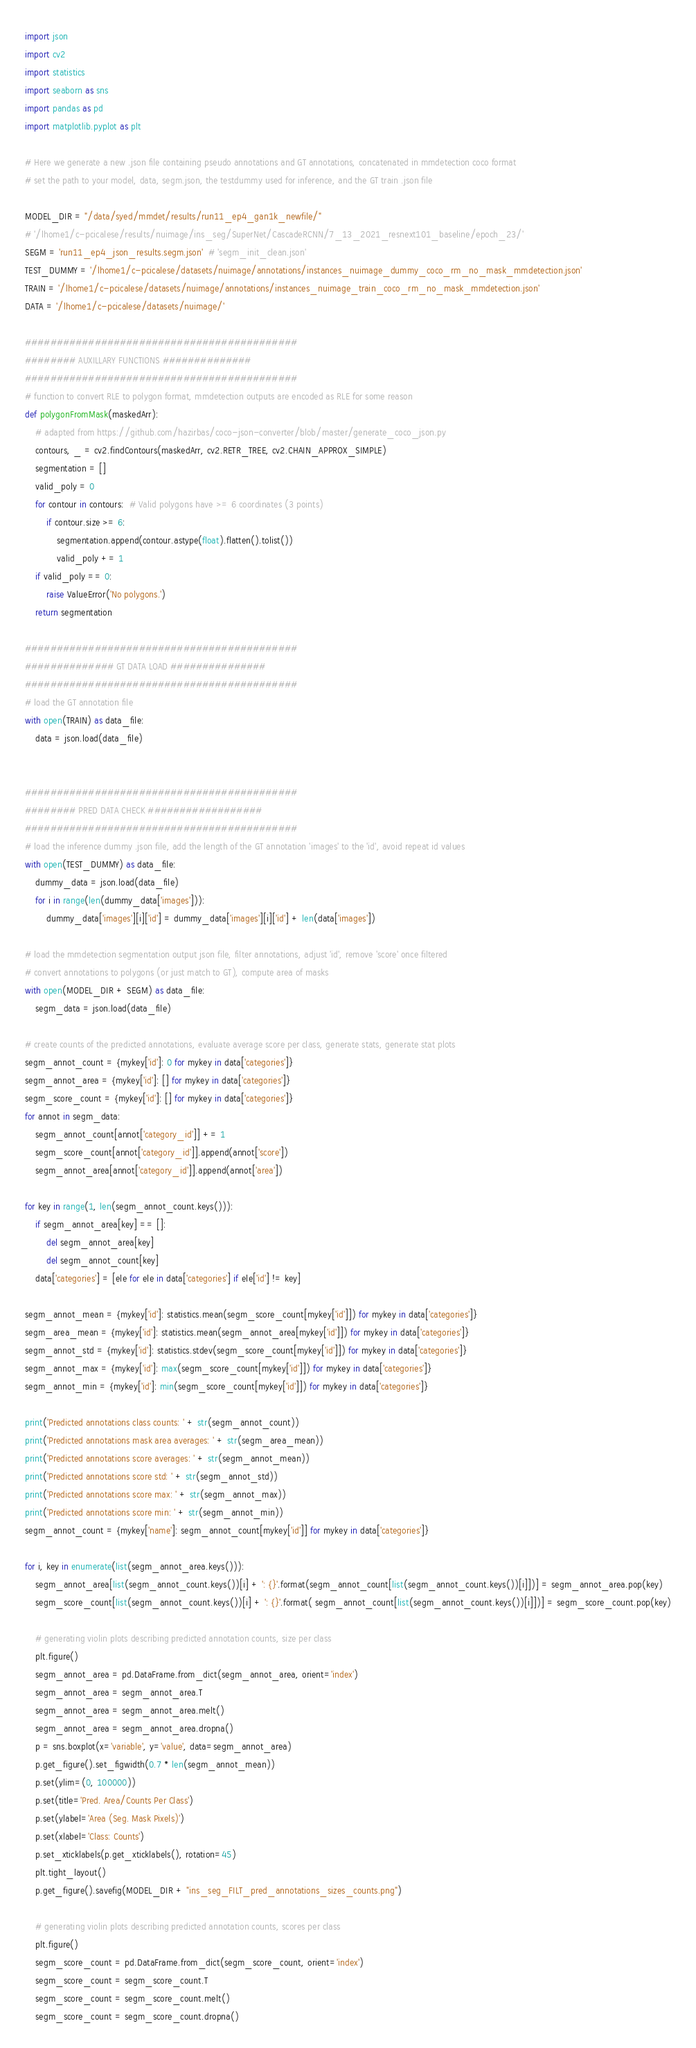Convert code to text. <code><loc_0><loc_0><loc_500><loc_500><_Python_>import json
import cv2
import statistics
import seaborn as sns
import pandas as pd
import matplotlib.pyplot as plt

# Here we generate a new .json file containing pseudo annotations and GT annotations, concatenated in mmdetection coco format
# set the path to your model, data, segm.json, the testdummy used for inference, and the GT train .json file

MODEL_DIR = "/data/syed/mmdet/results/run11_ep4_gan1k_newfile/"
# '/lhome1/c-pcicalese/results/nuimage/ins_seg/SuperNet/CascadeRCNN/7_13_2021_resnext101_baseline/epoch_23/'
SEGM = 'run11_ep4_json_results.segm.json'  # 'segm_init_clean.json'
TEST_DUMMY = '/lhome1/c-pcicalese/datasets/nuimage/annotations/instances_nuimage_dummy_coco_rm_no_mask_mmdetection.json'
TRAIN = '/lhome1/c-pcicalese/datasets/nuimage/annotations/instances_nuimage_train_coco_rm_no_mask_mmdetection.json'
DATA = '/lhome1/c-pcicalese/datasets/nuimage/'

###########################################
######## AUXILLARY FUNCTIONS ##############
###########################################
# function to convert RLE to polygon format, mmdetection outputs are encoded as RLE for some reason
def polygonFromMask(maskedArr):
    # adapted from https://github.com/hazirbas/coco-json-converter/blob/master/generate_coco_json.py
    contours, _ = cv2.findContours(maskedArr, cv2.RETR_TREE, cv2.CHAIN_APPROX_SIMPLE)
    segmentation = []
    valid_poly = 0
    for contour in contours:  # Valid polygons have >= 6 coordinates (3 points)
        if contour.size >= 6:
            segmentation.append(contour.astype(float).flatten().tolist())
            valid_poly += 1
    if valid_poly == 0:
        raise ValueError('No polygons.')
    return segmentation

###########################################
############## GT DATA LOAD ###############
###########################################
# load the GT annotation file
with open(TRAIN) as data_file:
    data = json.load(data_file)


###########################################
######## PRED DATA CHECK ##################
###########################################
# load the inference dummy .json file, add the length of the GT annotation 'images' to the 'id', avoid repeat id values
with open(TEST_DUMMY) as data_file:
    dummy_data = json.load(data_file)
    for i in range(len(dummy_data['images'])):
        dummy_data['images'][i]['id'] = dummy_data['images'][i]['id'] + len(data['images'])

# load the mmdetection segmentation output json file, filter annotations, adjust 'id', remove 'score' once filtered
# convert annotations to polygons (or just match to GT), compute area of masks
with open(MODEL_DIR + SEGM) as data_file:
    segm_data = json.load(data_file)

# create counts of the predicted annotations, evaluate average score per class, generate stats, generate stat plots
segm_annot_count = {mykey['id']: 0 for mykey in data['categories']}
segm_annot_area = {mykey['id']: [] for mykey in data['categories']}
segm_score_count = {mykey['id']: [] for mykey in data['categories']}
for annot in segm_data:
    segm_annot_count[annot['category_id']] += 1
    segm_score_count[annot['category_id']].append(annot['score'])
    segm_annot_area[annot['category_id']].append(annot['area'])

for key in range(1, len(segm_annot_count.keys())):
    if segm_annot_area[key] == []:
        del segm_annot_area[key]
        del segm_annot_count[key]
    data['categories'] = [ele for ele in data['categories'] if ele['id'] != key]

segm_annot_mean = {mykey['id']: statistics.mean(segm_score_count[mykey['id']]) for mykey in data['categories']}
segm_area_mean = {mykey['id']: statistics.mean(segm_annot_area[mykey['id']]) for mykey in data['categories']}
segm_annot_std = {mykey['id']: statistics.stdev(segm_score_count[mykey['id']]) for mykey in data['categories']}
segm_annot_max = {mykey['id']: max(segm_score_count[mykey['id']]) for mykey in data['categories']}
segm_annot_min = {mykey['id']: min(segm_score_count[mykey['id']]) for mykey in data['categories']}

print('Predicted annotations class counts: ' + str(segm_annot_count))
print('Predicted annotations mask area averages: ' + str(segm_area_mean))
print('Predicted annotations score averages: ' + str(segm_annot_mean))
print('Predicted annotations score std: ' + str(segm_annot_std))
print('Predicted annotations score max: ' + str(segm_annot_max))
print('Predicted annotations score min: ' + str(segm_annot_min))
segm_annot_count = {mykey['name']: segm_annot_count[mykey['id']] for mykey in data['categories']}

for i, key in enumerate(list(segm_annot_area.keys())):
    segm_annot_area[list(segm_annot_count.keys())[i] + ': {}'.format(segm_annot_count[list(segm_annot_count.keys())[i]])] = segm_annot_area.pop(key)
    segm_score_count[list(segm_annot_count.keys())[i] + ': {}'.format( segm_annot_count[list(segm_annot_count.keys())[i]])] = segm_score_count.pop(key)

    # generating violin plots describing predicted annotation counts, size per class
    plt.figure()
    segm_annot_area = pd.DataFrame.from_dict(segm_annot_area, orient='index')
    segm_annot_area = segm_annot_area.T
    segm_annot_area = segm_annot_area.melt()
    segm_annot_area = segm_annot_area.dropna()
    p = sns.boxplot(x='variable', y='value', data=segm_annot_area)
    p.get_figure().set_figwidth(0.7 * len(segm_annot_mean))
    p.set(ylim=(0, 100000))
    p.set(title='Pred. Area/Counts Per Class')
    p.set(ylabel='Area (Seg. Mask Pixels)')
    p.set(xlabel='Class: Counts')
    p.set_xticklabels(p.get_xticklabels(), rotation=45)
    plt.tight_layout()
    p.get_figure().savefig(MODEL_DIR + "ins_seg_FILT_pred_annotations_sizes_counts.png")

    # generating violin plots describing predicted annotation counts, scores per class
    plt.figure()
    segm_score_count = pd.DataFrame.from_dict(segm_score_count, orient='index')
    segm_score_count = segm_score_count.T
    segm_score_count = segm_score_count.melt()
    segm_score_count = segm_score_count.dropna()</code> 